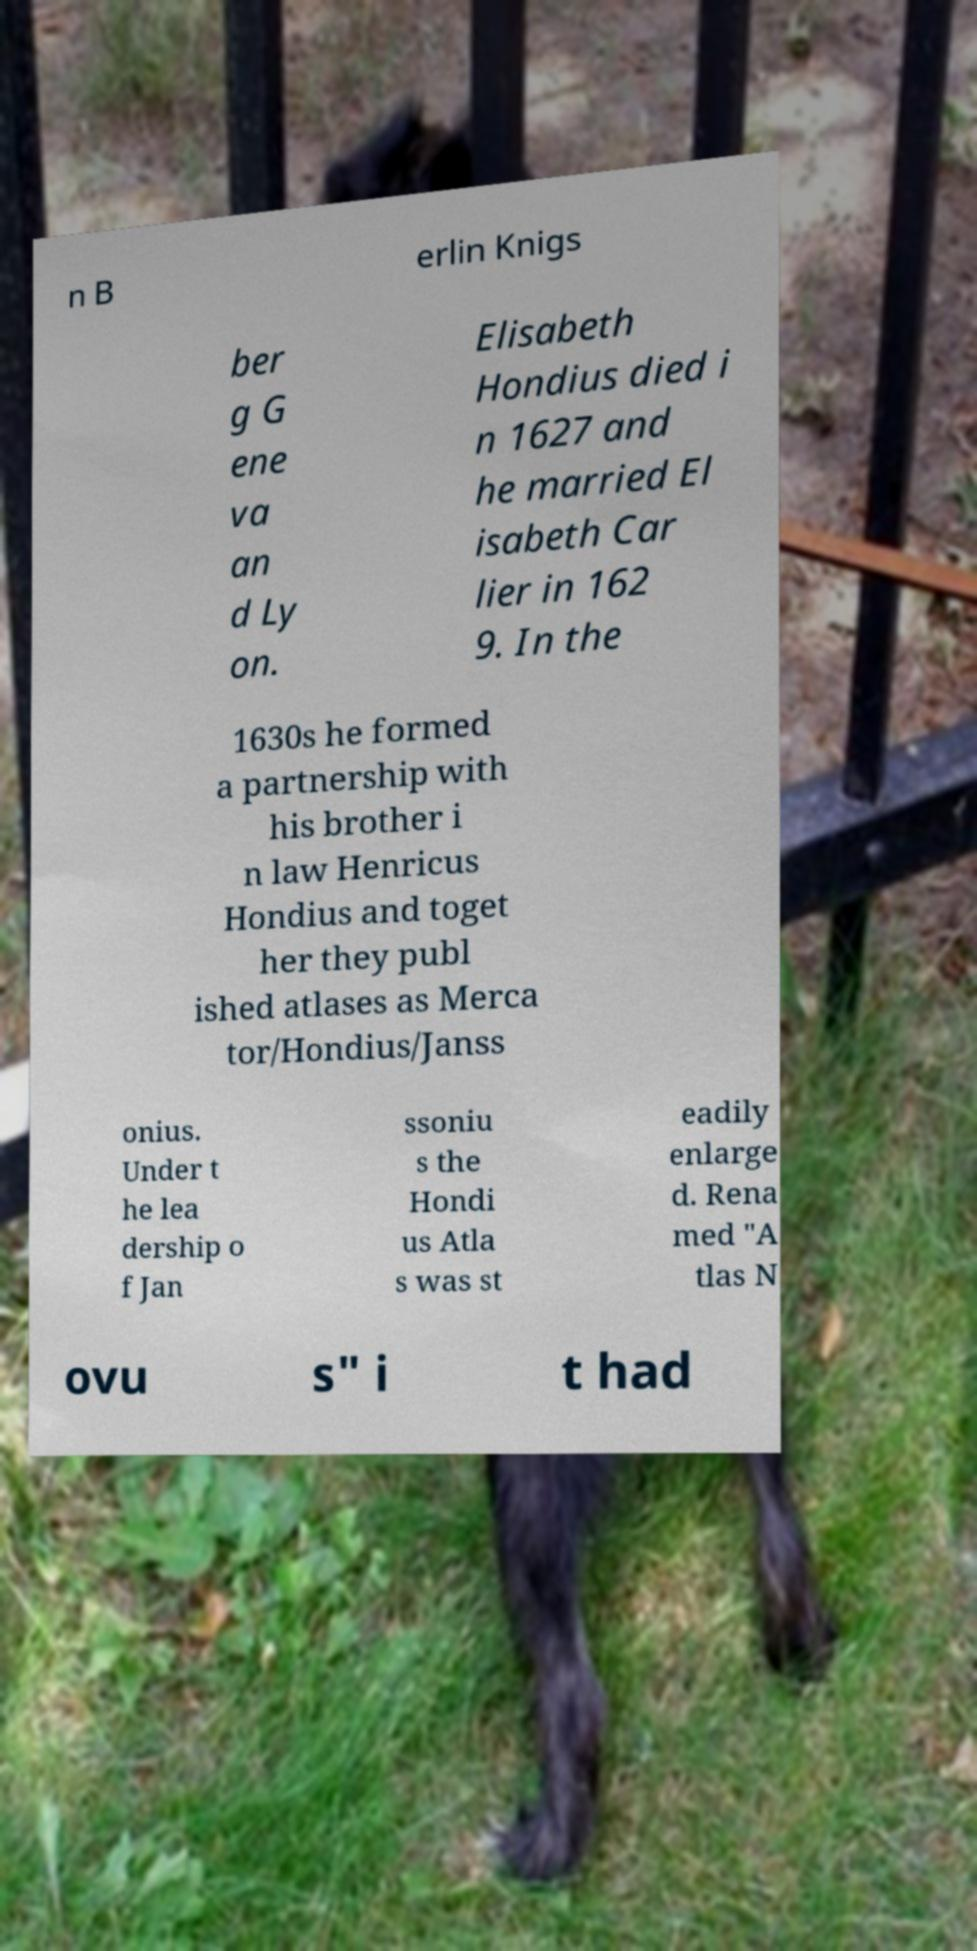Please identify and transcribe the text found in this image. n B erlin Knigs ber g G ene va an d Ly on. Elisabeth Hondius died i n 1627 and he married El isabeth Car lier in 162 9. In the 1630s he formed a partnership with his brother i n law Henricus Hondius and toget her they publ ished atlases as Merca tor/Hondius/Janss onius. Under t he lea dership o f Jan ssoniu s the Hondi us Atla s was st eadily enlarge d. Rena med "A tlas N ovu s" i t had 